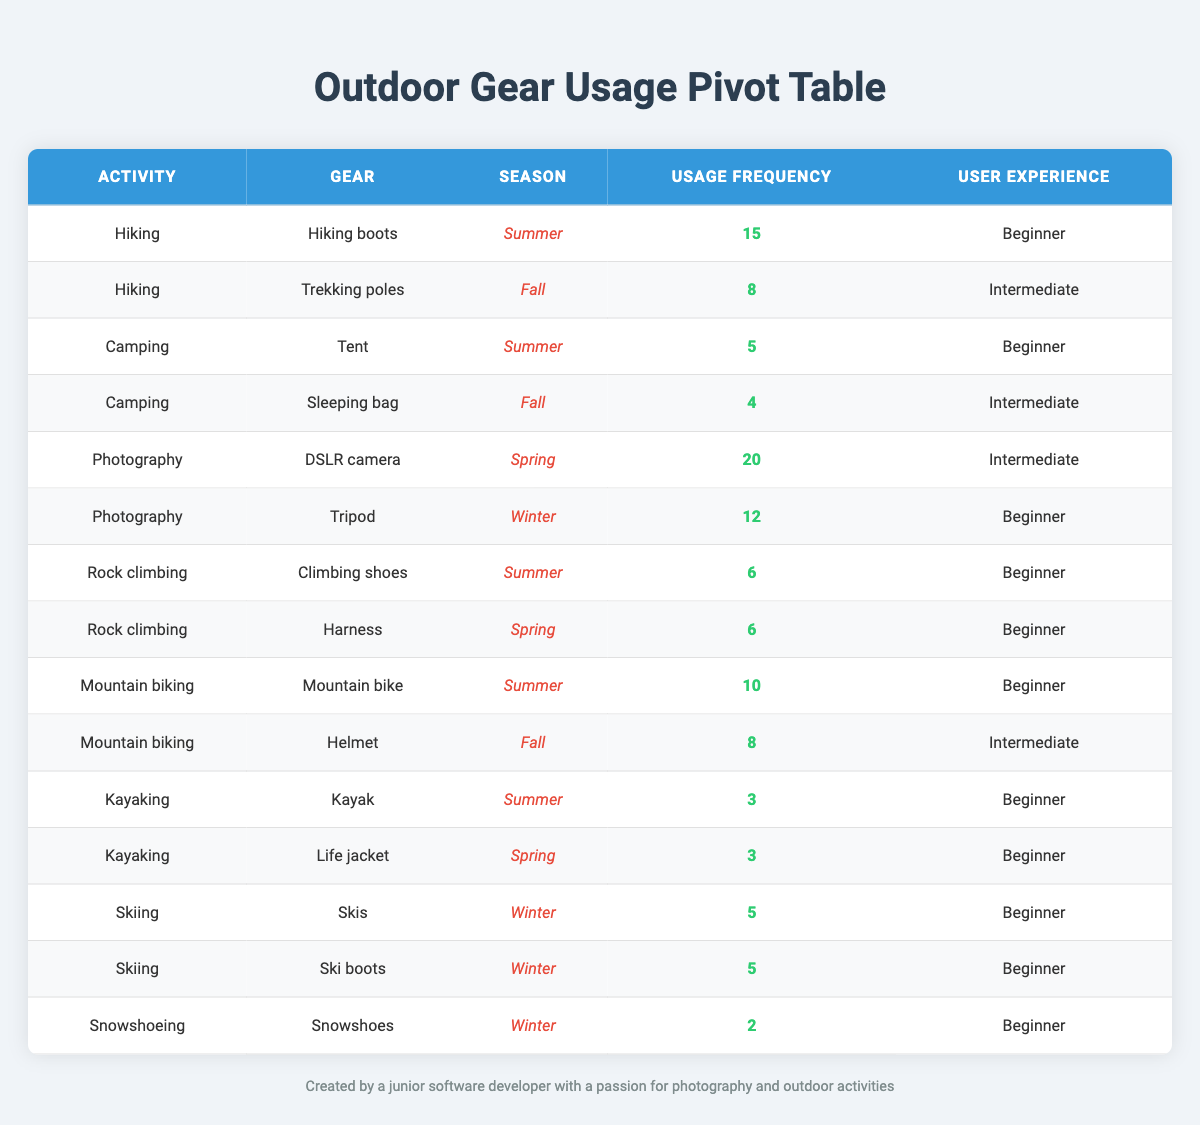What is the most frequently used gear for hiking in the summer? According to the table, the gear for hiking in the summer is "Hiking boots" with a usage frequency of 15. Since this is the only gear listed for summer hiking, it is the most frequently used.
Answer: Hiking boots How many different types of gear are used for winter activities? Examining the table, I see the gear for winter activities includes "Tripod", "Skis", "Ski boots", and "Snowshoes". That's a total of 4 unique types of gear for winter.
Answer: 4 What is the total usage frequency of gear for photography? To get the total usage frequency for photography, I sum the frequency of the gear: 20 (DSLR camera) + 12 (Tripod) = 32. Therefore, the total usage frequency is 32.
Answer: 32 Is the gear "Sleeping bag" used more frequently than "Snowshoes"? The usage frequency of the "Sleeping bag" is 4, while "Snowshoes" has a frequency of 2. Since 4 is greater than 2, it is true that the sleeping bag is used more frequently.
Answer: Yes Which season has the highest total usage frequency for hiking gear? For hiking, the gear usage in summer is 15 (Hiking boots) and for fall is 8 (Trekking poles). To find the total usage frequency, add these two: 15 + 8 = 23. Since 15 in summer is more than 8 in fall, summer has the highest total usage frequency for hiking gear.
Answer: Summer 